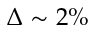<formula> <loc_0><loc_0><loc_500><loc_500>\Delta \sim 2 \%</formula> 